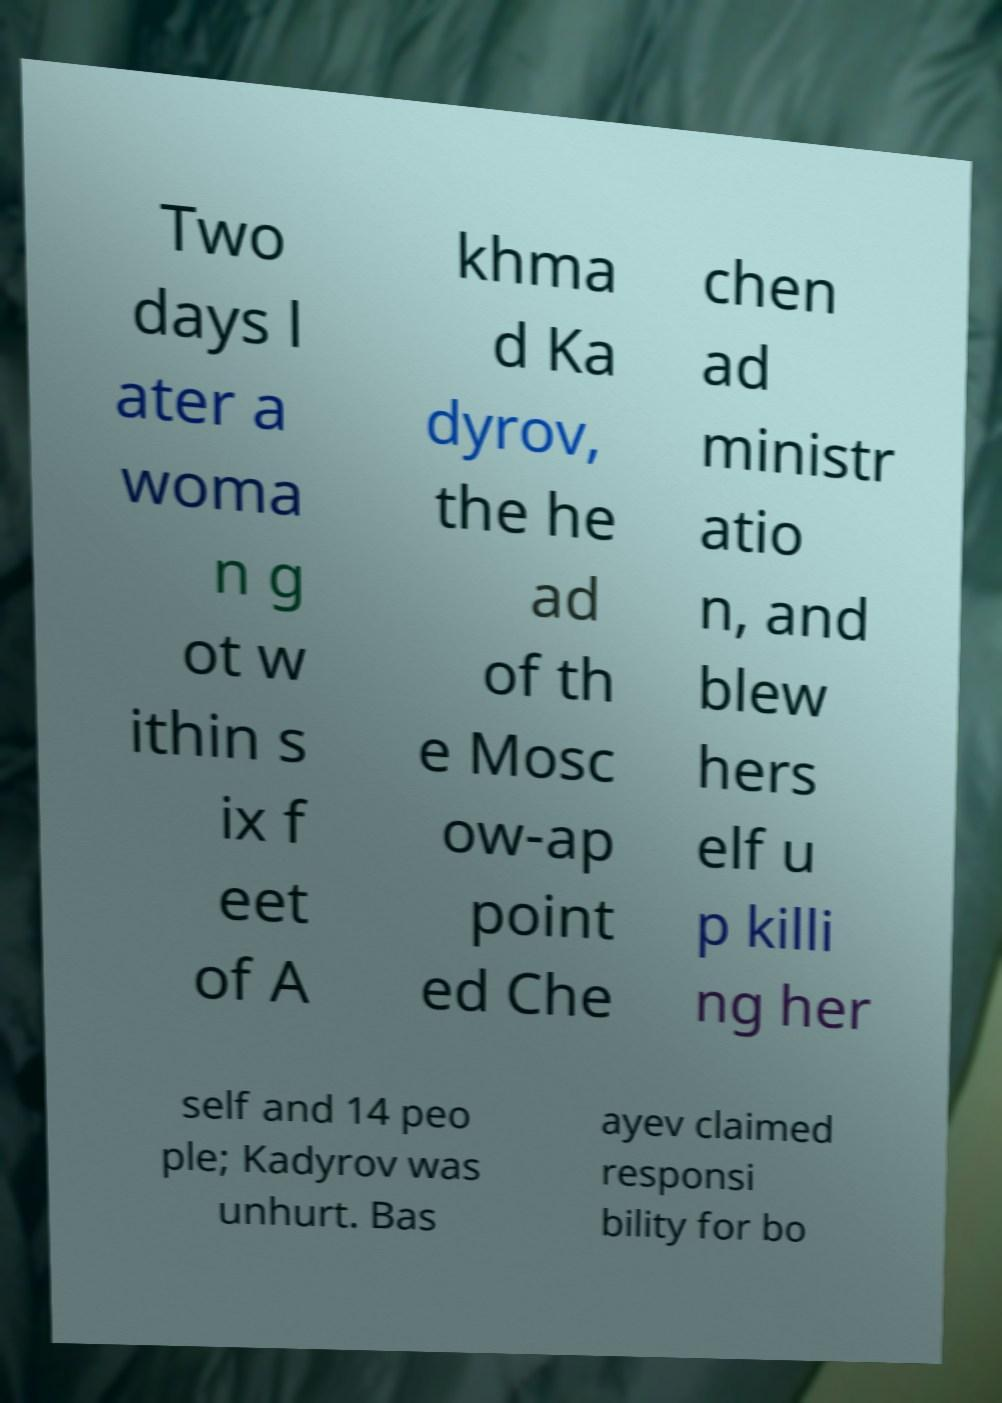Please read and relay the text visible in this image. What does it say? Two days l ater a woma n g ot w ithin s ix f eet of A khma d Ka dyrov, the he ad of th e Mosc ow-ap point ed Che chen ad ministr atio n, and blew hers elf u p killi ng her self and 14 peo ple; Kadyrov was unhurt. Bas ayev claimed responsi bility for bo 